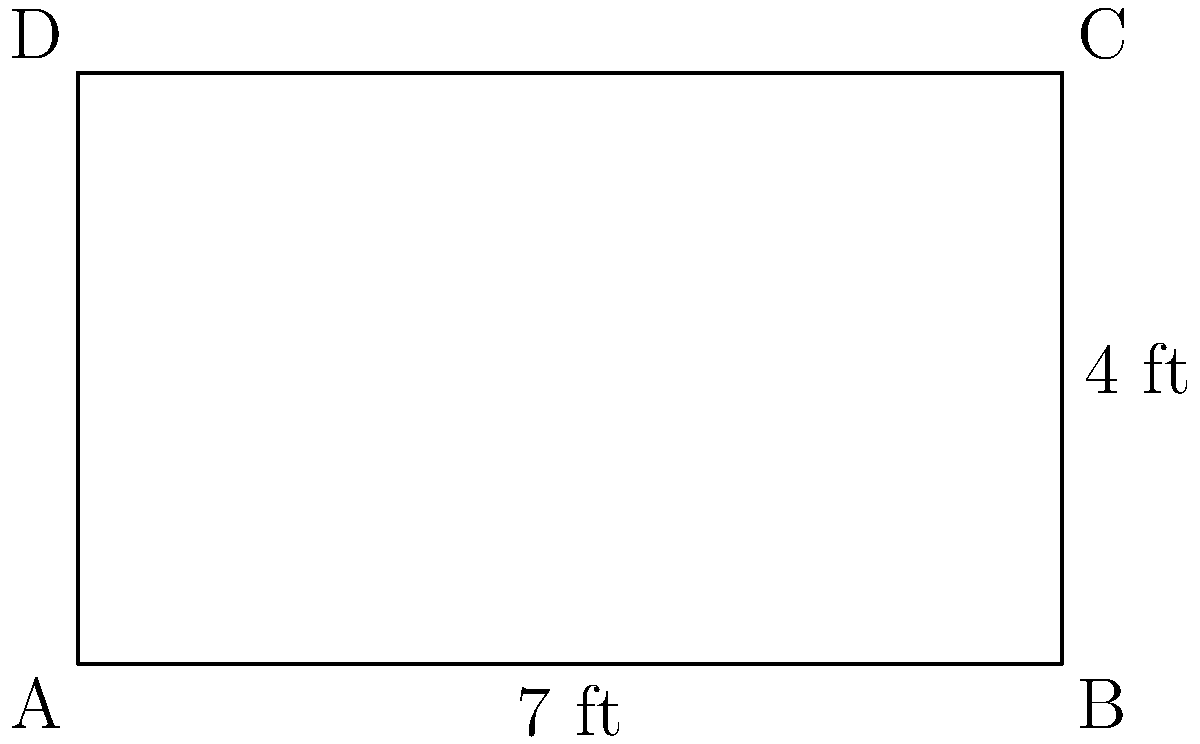A new rectangular massage table has arrived at the spa. Its length is 7 feet and its width is 4 feet. To order a custom-fit protective cover, you need to calculate the perimeter of the table. What is the perimeter of the massage table in feet? To find the perimeter of a rectangle, we need to follow these steps:

1. Identify the length and width of the rectangle:
   Length (l) = 7 feet
   Width (w) = 4 feet

2. Recall the formula for the perimeter of a rectangle:
   Perimeter = 2 × (length + width) or P = 2(l + w)

3. Substitute the values into the formula:
   P = 2(7 + 4)

4. Calculate the sum inside the parentheses:
   P = 2(11)

5. Multiply:
   P = 22

Therefore, the perimeter of the massage table is 22 feet.
Answer: 22 feet 